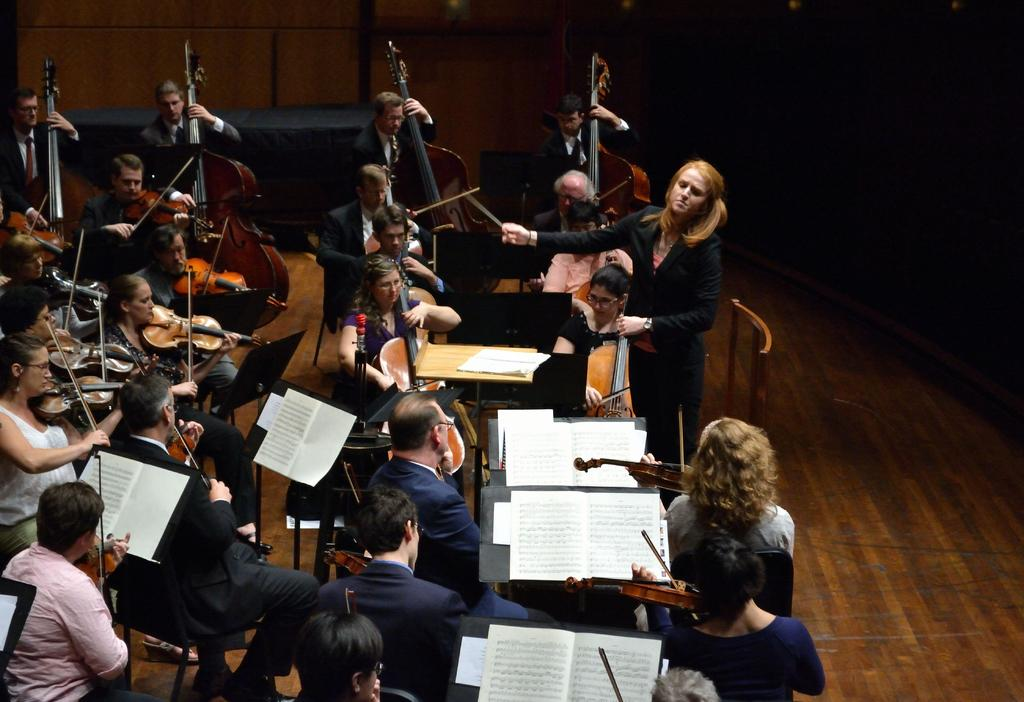Who are the subjects in the image? There are people in the image. What are the people doing in the image? The people are playing violins. How are the violins being held by the people? The violins are held in their hands. What can be seen in front of the people? There are notes in front of the people. What type of treatment is the farmer providing to the violins in the image? There is no farmer present in the image, and the people are playing the violins, not receiving any treatment. 